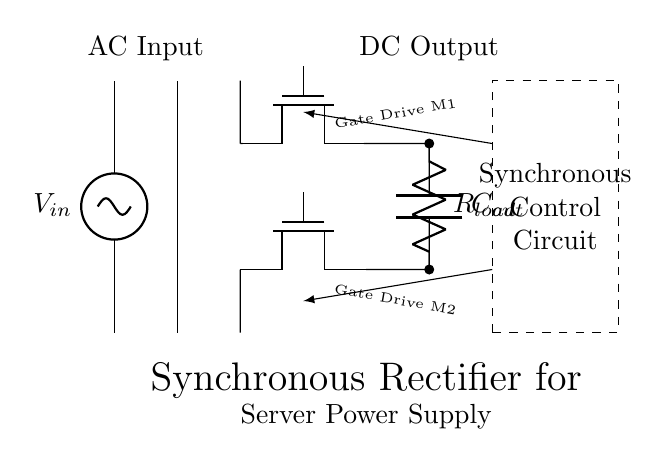What type of rectifier is shown in the circuit? The circuit uses a synchronous rectifier which utilizes MOSFETs instead of diodes to improve efficiency by reducing voltage drops during rectification.
Answer: Synchronous What components are used in the bridge rectifier? The bridge rectifier in this circuit is made up of two N-channel MOSFETs, identified as M1 and M2, which replace traditional diodes to minimize losses.
Answer: Two MOSFETs What is the role of the control circuitry? The control circuitry provides gate drive signals to the MOSFETs, enabling them to turn on and off at the appropriate times to effectively rectify the AC input to DC output.
Answer: Gate drive control What is the output voltage type of this circuit? The output voltage represents a direct current (DC) after the rectification process takes place, converting alternating current (AC) input.
Answer: Direct current How do the MOSFETs contribute to power efficiency? The MOSFETs in the synchronous rectifier reduce conduction losses compared to diodes, as they can be switched on and off more quickly, thus minimizing power loss during the rectification process.
Answer: Reduced conduction losses What is the purpose of the output capacitor in this circuit? The output capacitor smooths the DC output voltage by filtering out the ripple caused by the rectification process, resulting in a more stable DC signal for the load.
Answer: Smoothing the output voltage 